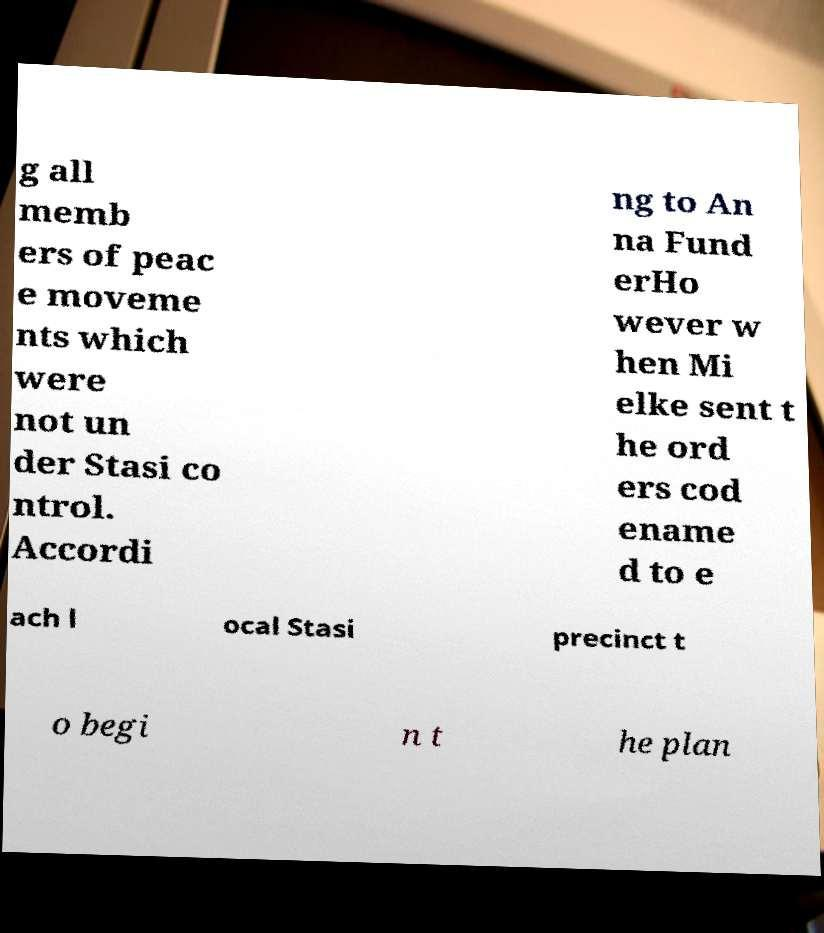Could you assist in decoding the text presented in this image and type it out clearly? g all memb ers of peac e moveme nts which were not un der Stasi co ntrol. Accordi ng to An na Fund erHo wever w hen Mi elke sent t he ord ers cod ename d to e ach l ocal Stasi precinct t o begi n t he plan 